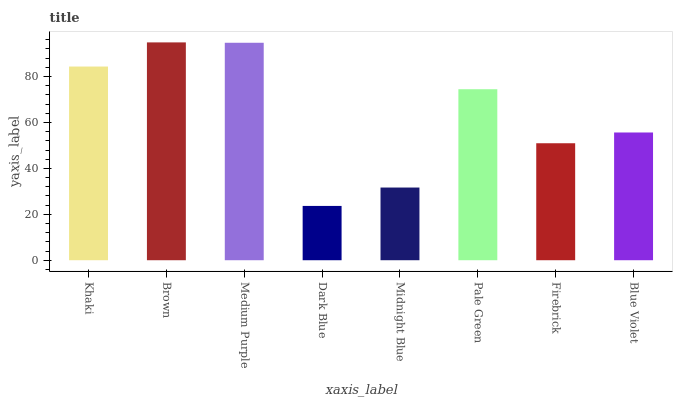Is Dark Blue the minimum?
Answer yes or no. Yes. Is Brown the maximum?
Answer yes or no. Yes. Is Medium Purple the minimum?
Answer yes or no. No. Is Medium Purple the maximum?
Answer yes or no. No. Is Brown greater than Medium Purple?
Answer yes or no. Yes. Is Medium Purple less than Brown?
Answer yes or no. Yes. Is Medium Purple greater than Brown?
Answer yes or no. No. Is Brown less than Medium Purple?
Answer yes or no. No. Is Pale Green the high median?
Answer yes or no. Yes. Is Blue Violet the low median?
Answer yes or no. Yes. Is Medium Purple the high median?
Answer yes or no. No. Is Pale Green the low median?
Answer yes or no. No. 